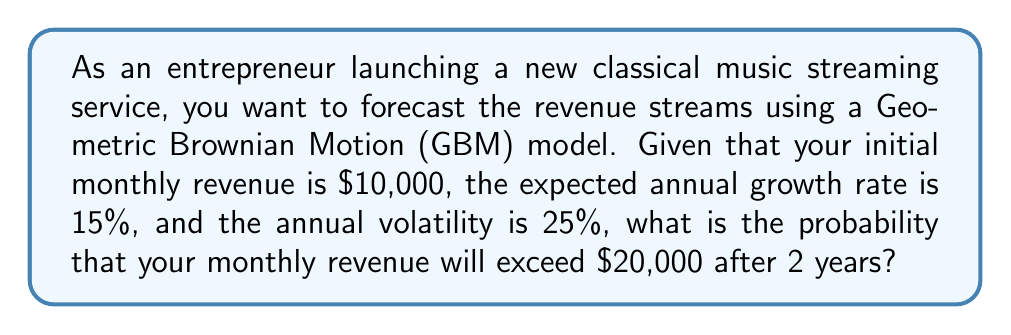Give your solution to this math problem. Let's approach this step-by-step using the Geometric Brownian Motion model:

1) The GBM model is given by the equation:
   $$S_t = S_0 \exp\left(\left(\mu - \frac{\sigma^2}{2}\right)t + \sigma W_t\right)$$
   where $S_t$ is the revenue at time $t$, $S_0$ is the initial revenue, $\mu$ is the drift (expected return), $\sigma$ is the volatility, and $W_t$ is a Wiener process.

2) We're given:
   $S_0 = 10,000$
   $\mu = 15\% = 0.15$ (annual)
   $\sigma = 25\% = 0.25$ (annual)
   $t = 2$ years

3) In the GBM model, $\ln(S_t/S_0)$ follows a normal distribution with mean $(\mu - \frac{\sigma^2}{2})t$ and variance $\sigma^2t$.

4) We want to find $P(S_t > 20,000)$, which is equivalent to $P(\ln(S_t/S_0) > \ln(20,000/10,000))$

5) Calculate the mean of $\ln(S_t/S_0)$:
   $$(\mu - \frac{\sigma^2}{2})t = (0.15 - \frac{0.25^2}{2}) \cdot 2 = 0.23125$$

6) Calculate the standard deviation of $\ln(S_t/S_0)$:
   $$\sigma\sqrt{t} = 0.25\sqrt{2} = 0.3535534$$

7) Calculate the z-score:
   $$z = \frac{\ln(20,000/10,000) - 0.23125}{0.3535534} = 1.3387$$

8) The probability is given by $1 - \Phi(z)$, where $\Phi$ is the standard normal cumulative distribution function.

9) Using a standard normal table or calculator, we find:
   $$1 - \Phi(1.3387) \approx 0.0903$$

Therefore, the probability that the monthly revenue will exceed $20,000 after 2 years is approximately 0.0903 or 9.03%.
Answer: 0.0903 (or 9.03%) 